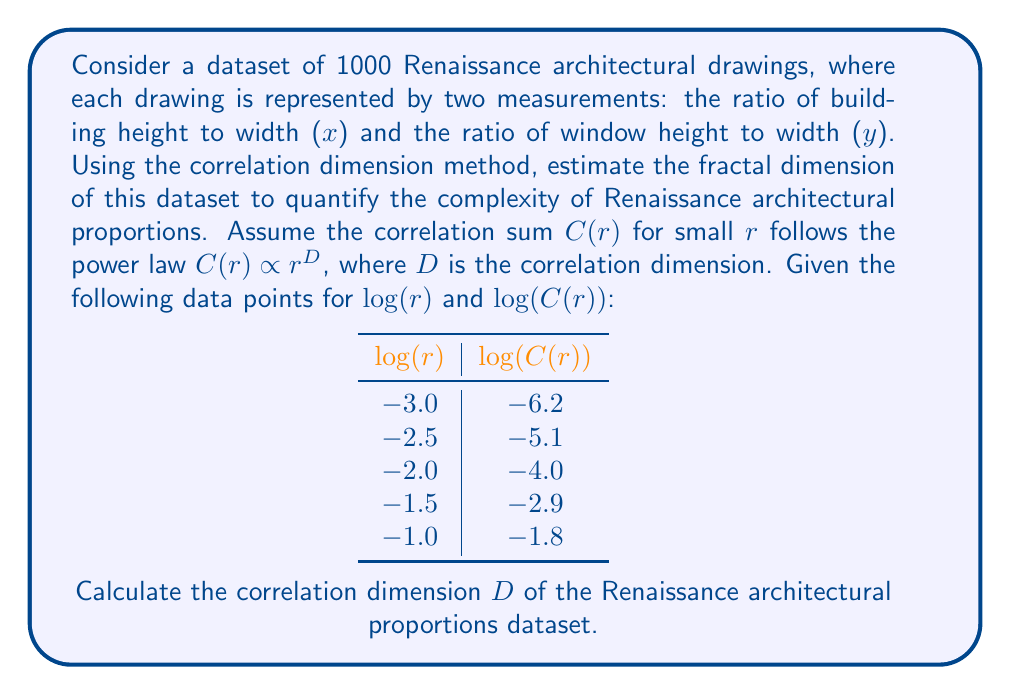Show me your answer to this math problem. To calculate the correlation dimension $D$, we need to follow these steps:

1) The correlation dimension $D$ is given by the slope of the line in the log-log plot of $C(r)$ vs $r$. We can use the formula:

   $$D = \frac{\Delta \log(C(r))}{\Delta \log(r)}$$

2) We can calculate this slope using any two points. Let's use the first and last points for maximum range:

   Point 1: $(\log(r_1), \log(C(r_1))) = (-3.0, -6.2)$
   Point 2: $(\log(r_2), \log(C(r_2))) = (-1.0, -1.8)$

3) Calculate $\Delta \log(r)$:
   $$\Delta \log(r) = \log(r_2) - \log(r_1) = -1.0 - (-3.0) = 2.0$$

4) Calculate $\Delta \log(C(r))$:
   $$\Delta \log(C(r)) = \log(C(r_2)) - \log(C(r_1)) = -1.8 - (-6.2) = 4.4$$

5) Calculate $D$:
   $$D = \frac{\Delta \log(C(r))}{\Delta \log(r)} = \frac{4.4}{2.0} = 2.2$$

Therefore, the correlation dimension $D$ of the Renaissance architectural proportions dataset is 2.2.
Answer: $D = 2.2$ 